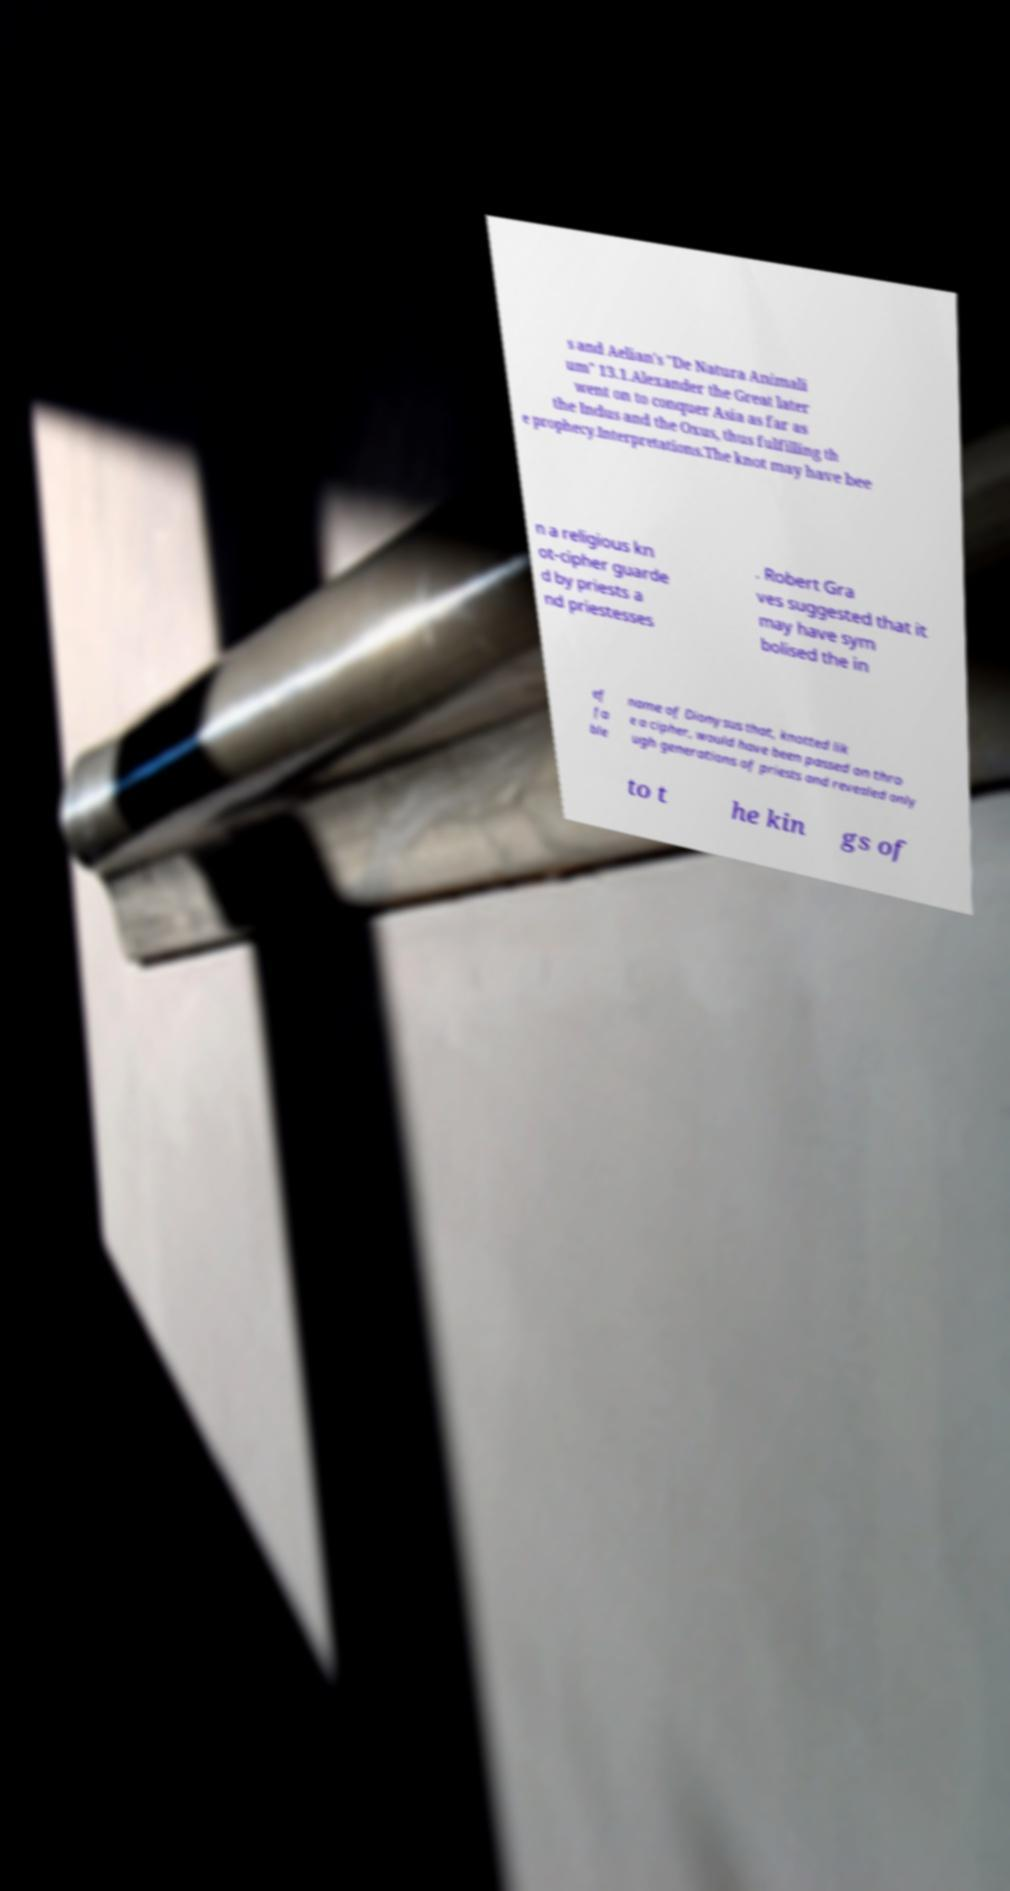Can you accurately transcribe the text from the provided image for me? s and Aelian's "De Natura Animali um" 13.1.Alexander the Great later went on to conquer Asia as far as the Indus and the Oxus, thus fulfilling th e prophecy.Interpretations.The knot may have bee n a religious kn ot-cipher guarde d by priests a nd priestesses . Robert Gra ves suggested that it may have sym bolised the in ef fa ble name of Dionysus that, knotted lik e a cipher, would have been passed on thro ugh generations of priests and revealed only to t he kin gs of 